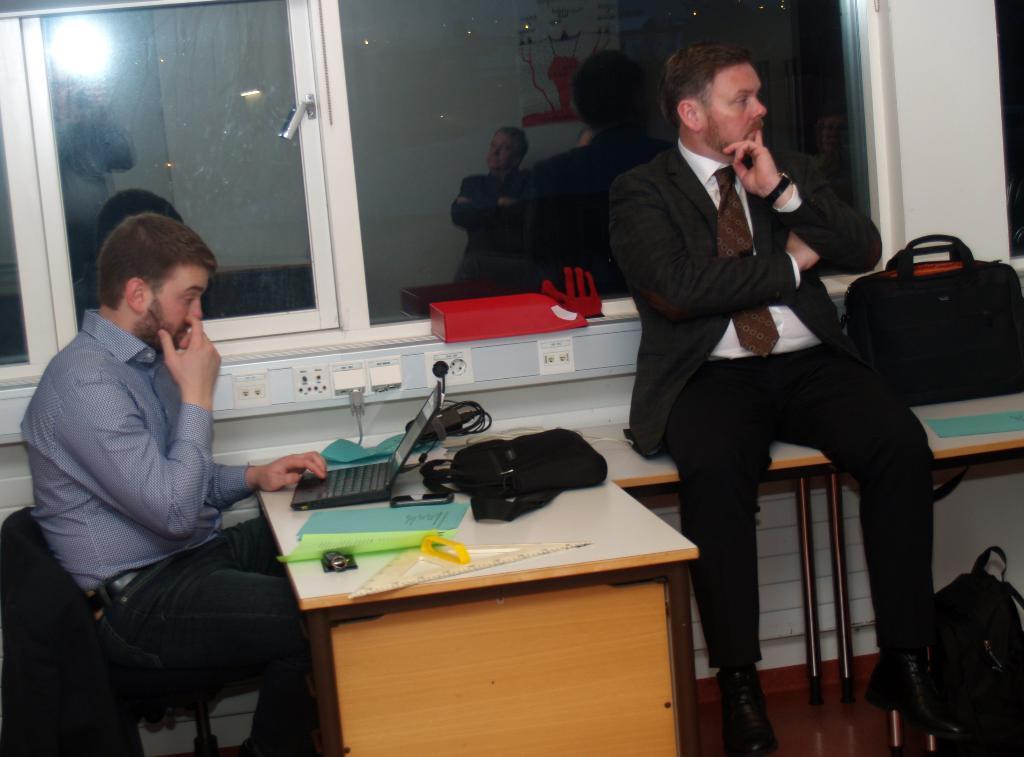Describe this image in one or two sentences. A man is sitting in a chair while working on a laptop. There are big,some file and other accessories on the table. There is another man sitting on a table beside with a bag on it. 